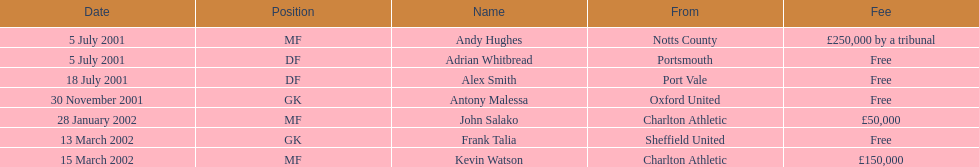Which transfer came subsequent to john salako's in 2002? Frank Talia. 